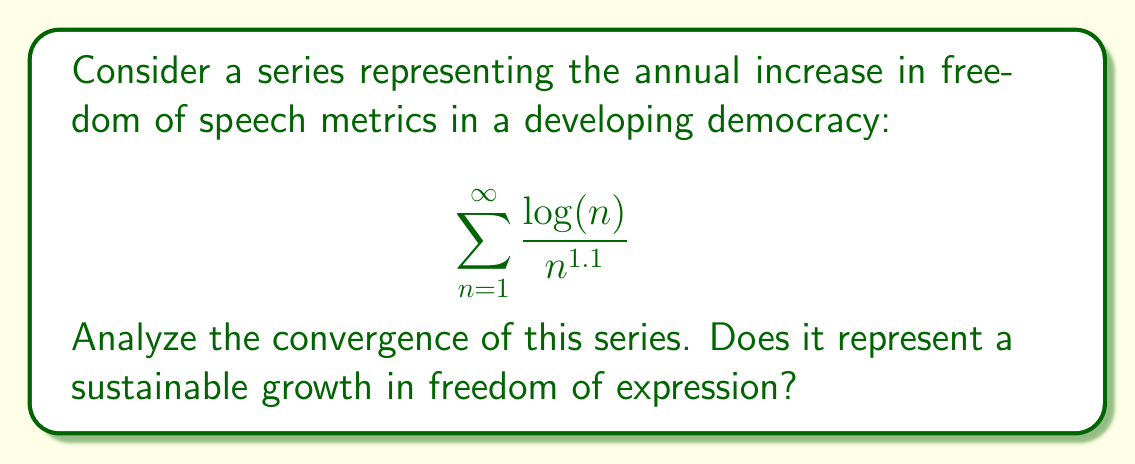Help me with this question. To analyze the convergence of this series, we'll use the limit comparison test with a p-series.

Step 1: Let's compare our series with the p-series $\sum_{n=1}^{\infty} \frac{1}{n^p}$ where $p = 1.1$.

Step 2: Form the limit of the ratio of the general terms:

$$\lim_{n \to \infty} \frac{\frac{\log(n)}{n^{1.1}}}{\frac{1}{n^{1.1}}} = \lim_{n \to \infty} \log(n)$$

Step 3: As $n$ approaches infinity, $\log(n)$ also approaches infinity.

Step 4: Since the limit is infinite, we cannot directly apply the limit comparison test. However, this suggests that our series diverges at least as fast as the comparison series.

Step 5: We know that $\sum_{n=1}^{\infty} \frac{1}{n^p}$ converges for $p > 1$ and diverges for $p \leq 1$.

Step 6: In our case, $p = 1.1 > 1$, so the comparison series converges.

Step 7: However, our original series has an additional $\log(n)$ term in the numerator, which grows faster than any power of $n$.

Step 8: Therefore, despite the comparison series converging, our original series diverges.

In the context of freedom of speech, this divergence suggests that the metrics are growing at an unsustainable rate in the long term. While this may indicate rapid initial progress, it's not a realistic model for sustained growth in freedom of expression.
Answer: The series diverges, indicating unsustainable growth. 